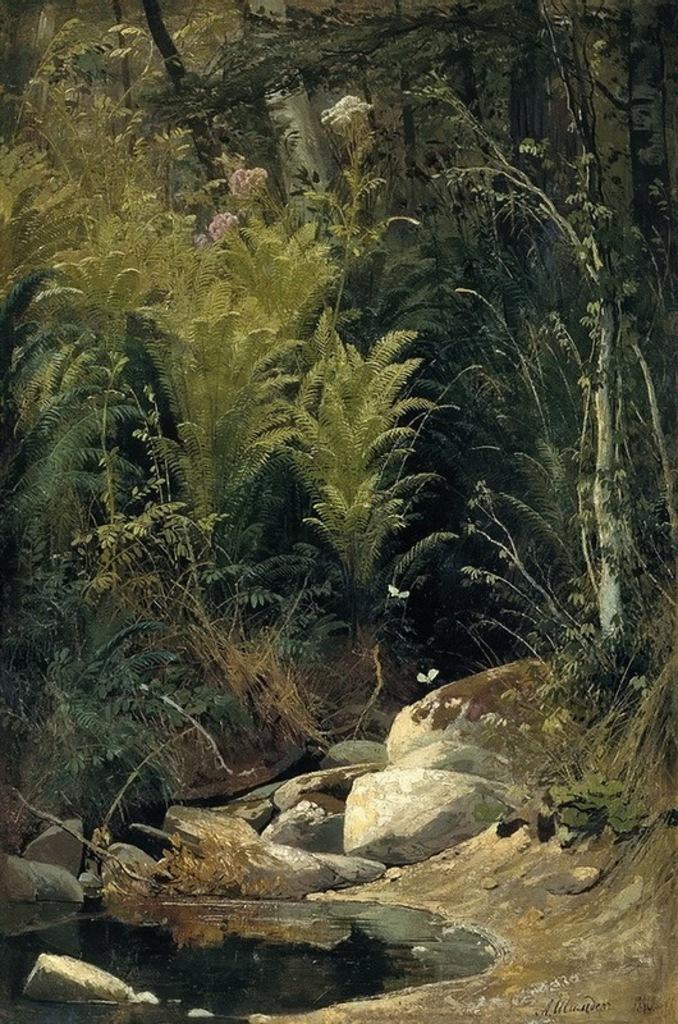In one or two sentences, can you explain what this image depicts? In this image I can see water, stones, grass, plants and trees. This image looks like a painting. 